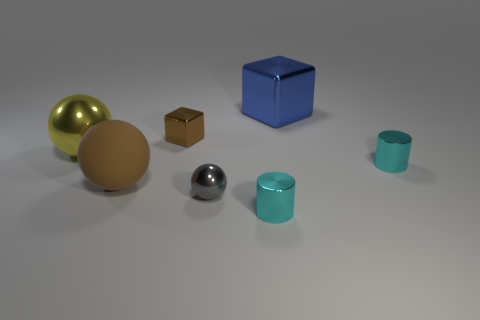Which objects in the image appear reflective, and what does that suggest about their material? The golden sphere on the left and the small chrome sphere towards the center appear to be reflective. This suggests that their material could be some type of metal or a shiny plastic with a high-gloss finish. Reflectivity often indicates a smooth and polished surface which we see in decorative items or well-designed functional objects meant to convey a sense of luxury or aesthetic appeal. 